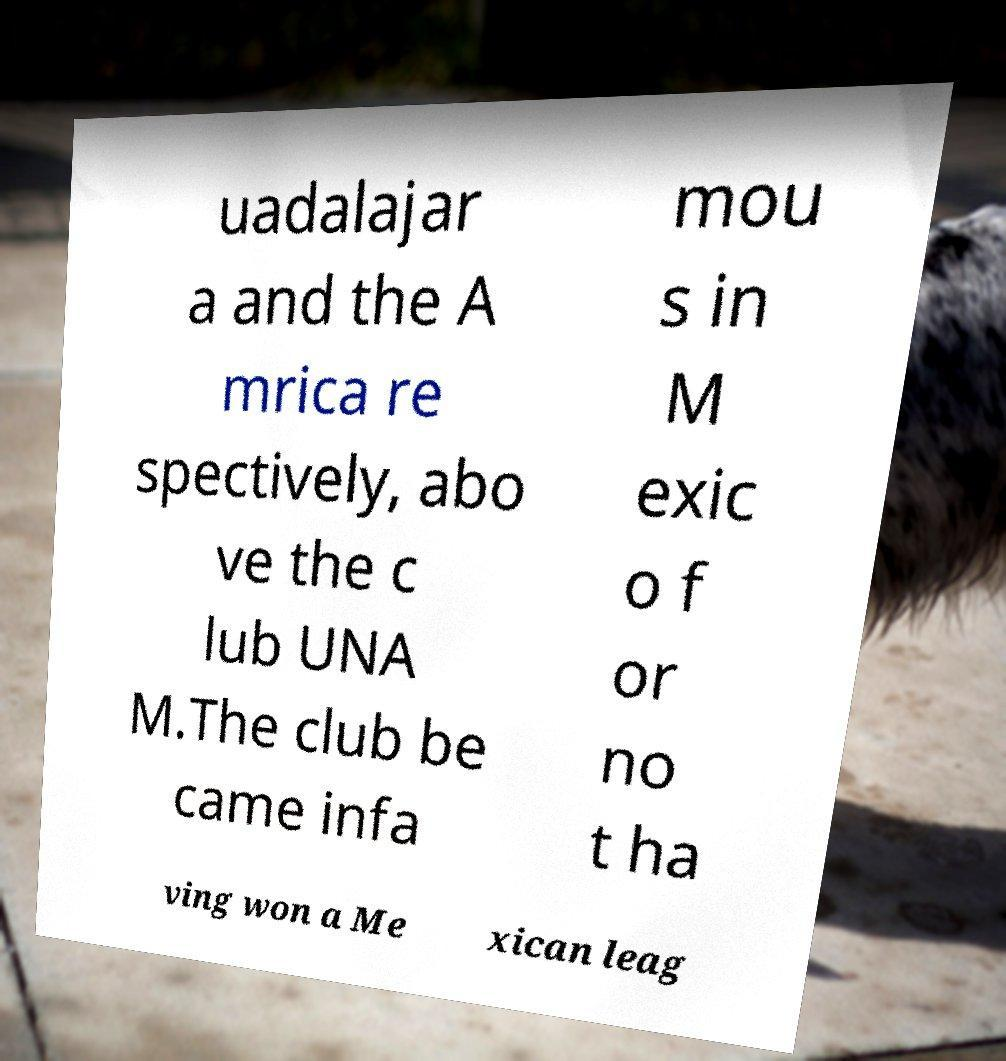Could you assist in decoding the text presented in this image and type it out clearly? uadalajar a and the A mrica re spectively, abo ve the c lub UNA M.The club be came infa mou s in M exic o f or no t ha ving won a Me xican leag 